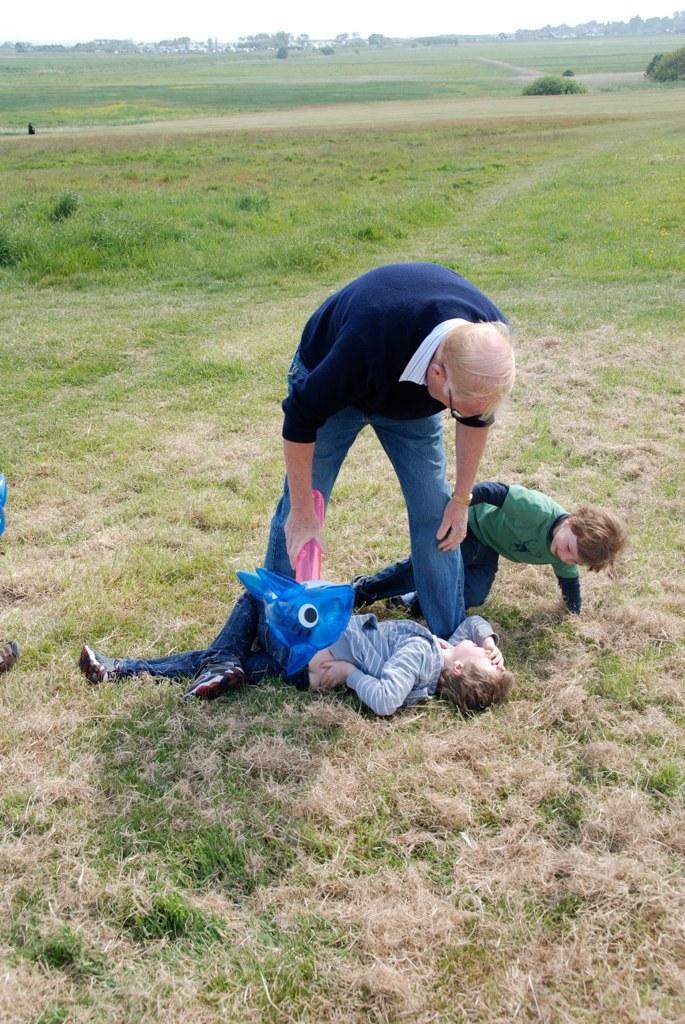Could you give a brief overview of what you see in this image? In this picture there is a man in the center of the image and there are two children in the center of the image, there is grassland around the area of the image. 